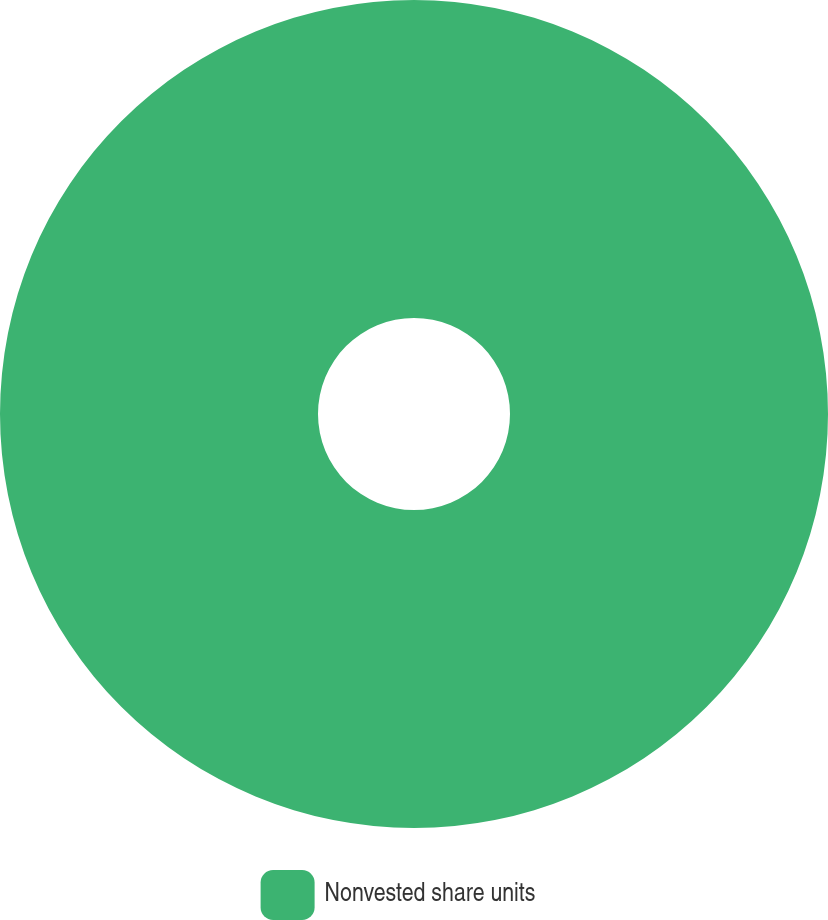Convert chart. <chart><loc_0><loc_0><loc_500><loc_500><pie_chart><fcel>Nonvested share units<nl><fcel>100.0%<nl></chart> 